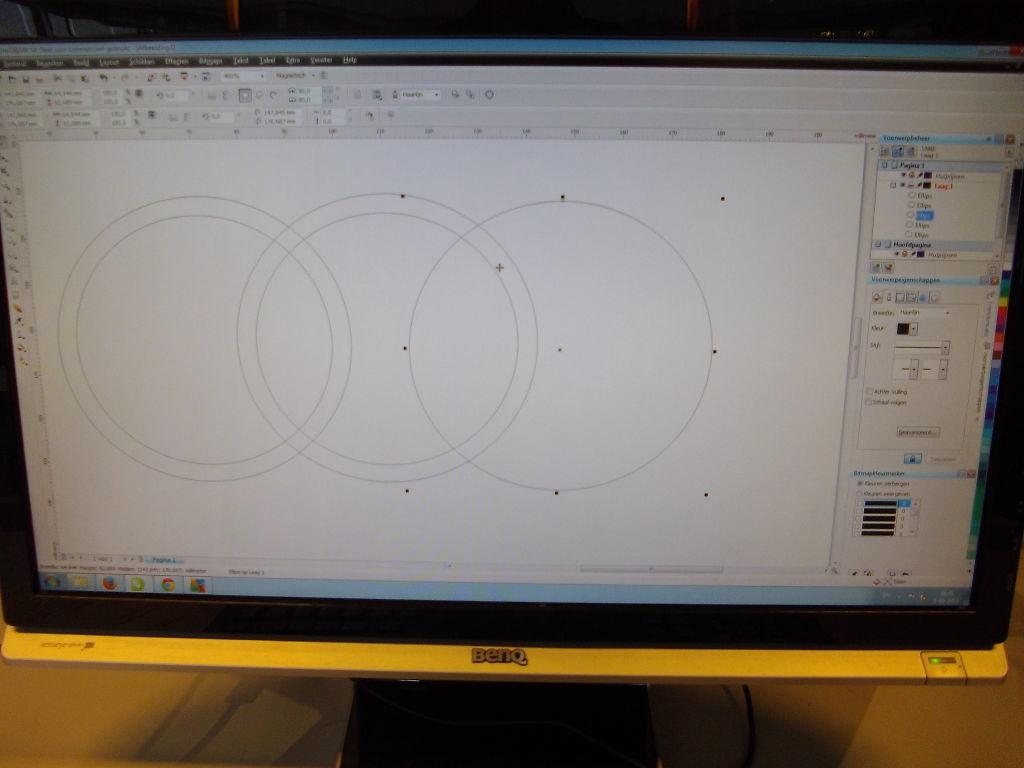<image>
Describe the image concisely. Benq computer monitor showing someone editing a circle. 